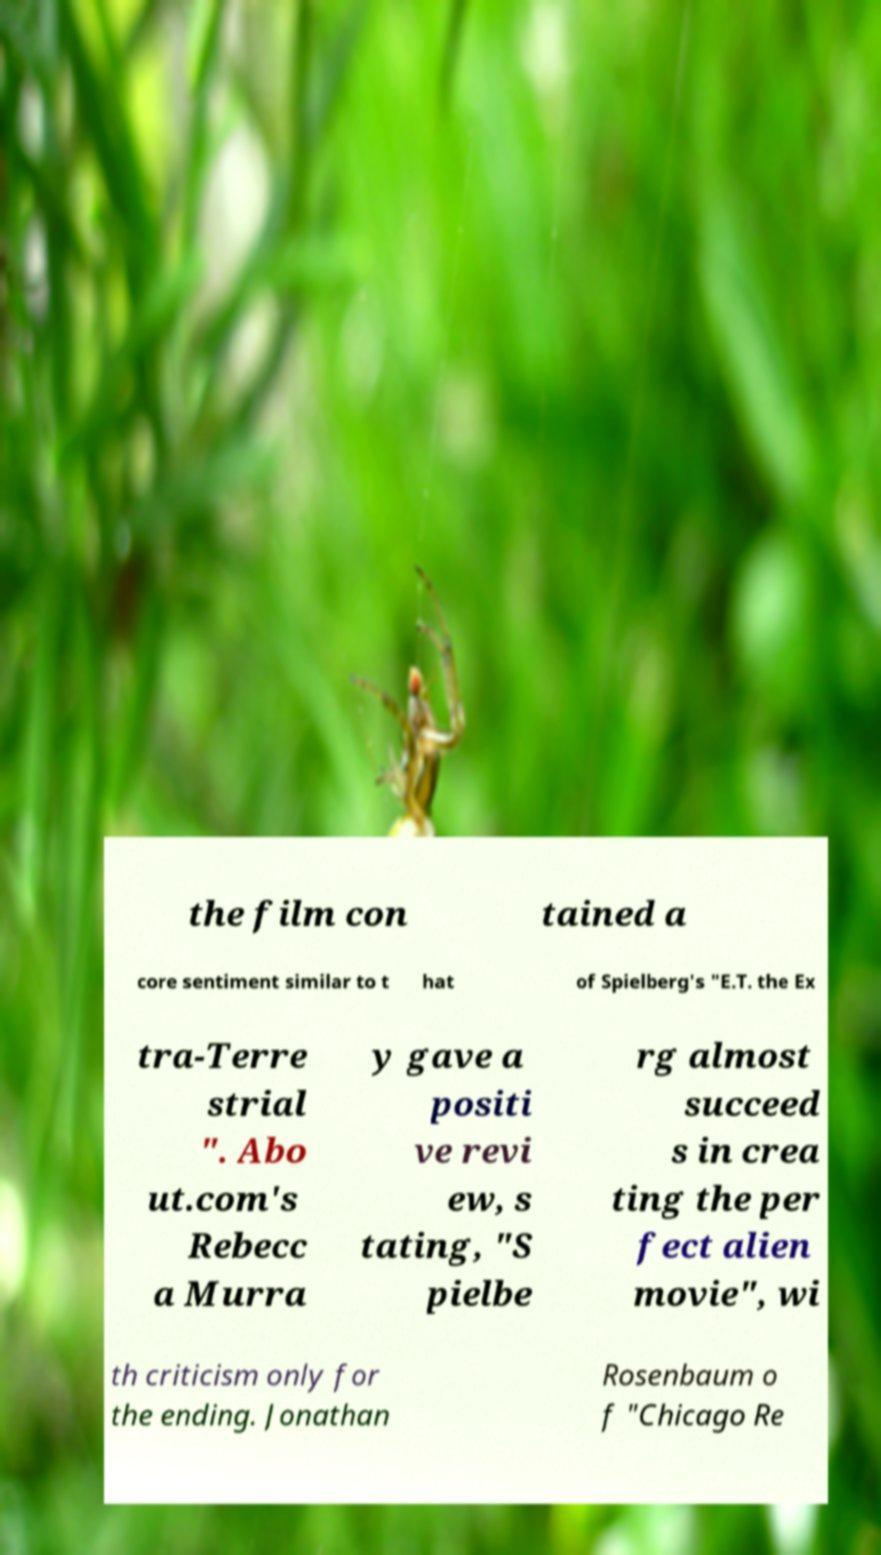Please read and relay the text visible in this image. What does it say? the film con tained a core sentiment similar to t hat of Spielberg's "E.T. the Ex tra-Terre strial ". Abo ut.com's Rebecc a Murra y gave a positi ve revi ew, s tating, "S pielbe rg almost succeed s in crea ting the per fect alien movie", wi th criticism only for the ending. Jonathan Rosenbaum o f "Chicago Re 